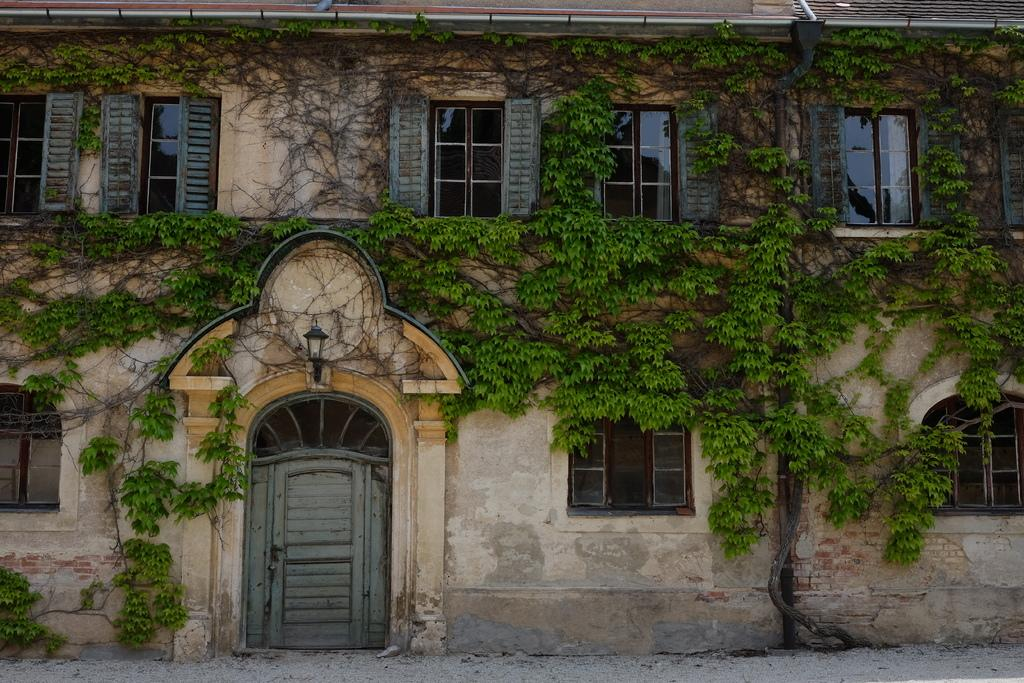What type of structure is in the image? There is a house in the image. What features can be seen on the house? The house has windows and a door. What object is present in the image that provides light? There is a lamp in the image. What type of vertical structures are visible in the image? There are poles in the image. How does the house rub its elbow in the image? There is no indication in the image that the house has an elbow or that it is capable of rubbing it. 